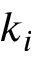Convert formula to latex. <formula><loc_0><loc_0><loc_500><loc_500>k _ { i }</formula> 